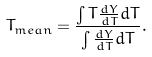Convert formula to latex. <formula><loc_0><loc_0><loc_500><loc_500>T _ { m e a n } = \frac { \int T \frac { d Y } { d T } d T } { \int \frac { d Y } { d T } d T } .</formula> 